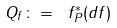<formula> <loc_0><loc_0><loc_500><loc_500>Q _ { f } \colon = \ f _ { P } ^ { * } ( d f )</formula> 